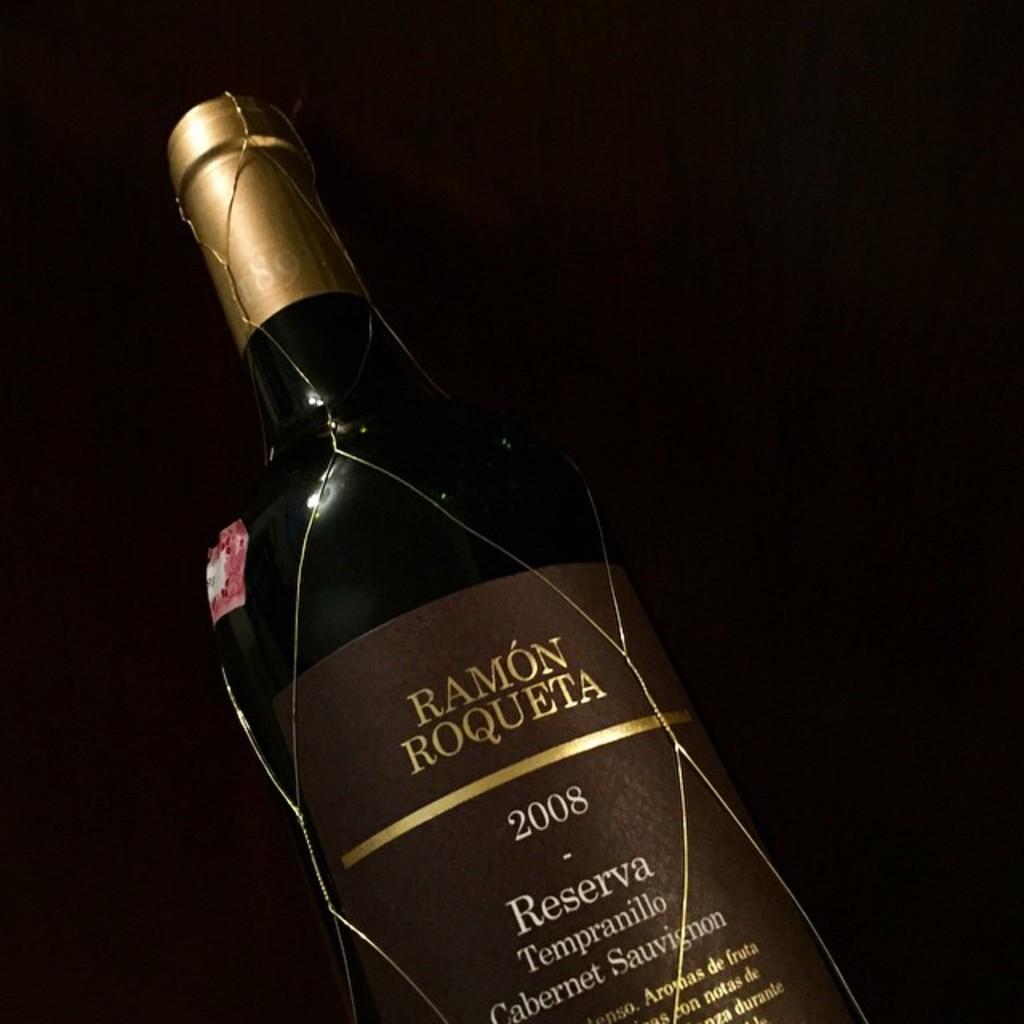What type of wine is this?
Ensure brevity in your answer.  Ramon roqueta. 